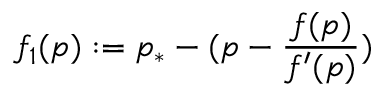<formula> <loc_0><loc_0><loc_500><loc_500>f _ { 1 } ( p ) \colon = p _ { * } - ( p - \frac { f ( p ) } { f ^ { \prime } ( p ) } )</formula> 